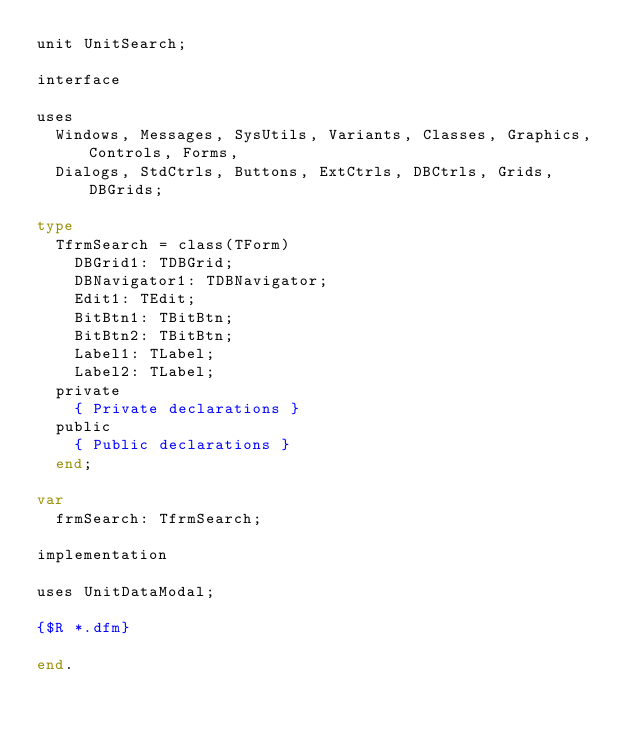<code> <loc_0><loc_0><loc_500><loc_500><_Pascal_>unit UnitSearch;

interface

uses
  Windows, Messages, SysUtils, Variants, Classes, Graphics, Controls, Forms,
  Dialogs, StdCtrls, Buttons, ExtCtrls, DBCtrls, Grids, DBGrids;

type
  TfrmSearch = class(TForm)
    DBGrid1: TDBGrid;
    DBNavigator1: TDBNavigator;
    Edit1: TEdit;
    BitBtn1: TBitBtn;
    BitBtn2: TBitBtn;
    Label1: TLabel;
    Label2: TLabel;
  private
    { Private declarations }
  public
    { Public declarations }
  end;

var
  frmSearch: TfrmSearch;

implementation

uses UnitDataModal;

{$R *.dfm}

end.
</code> 